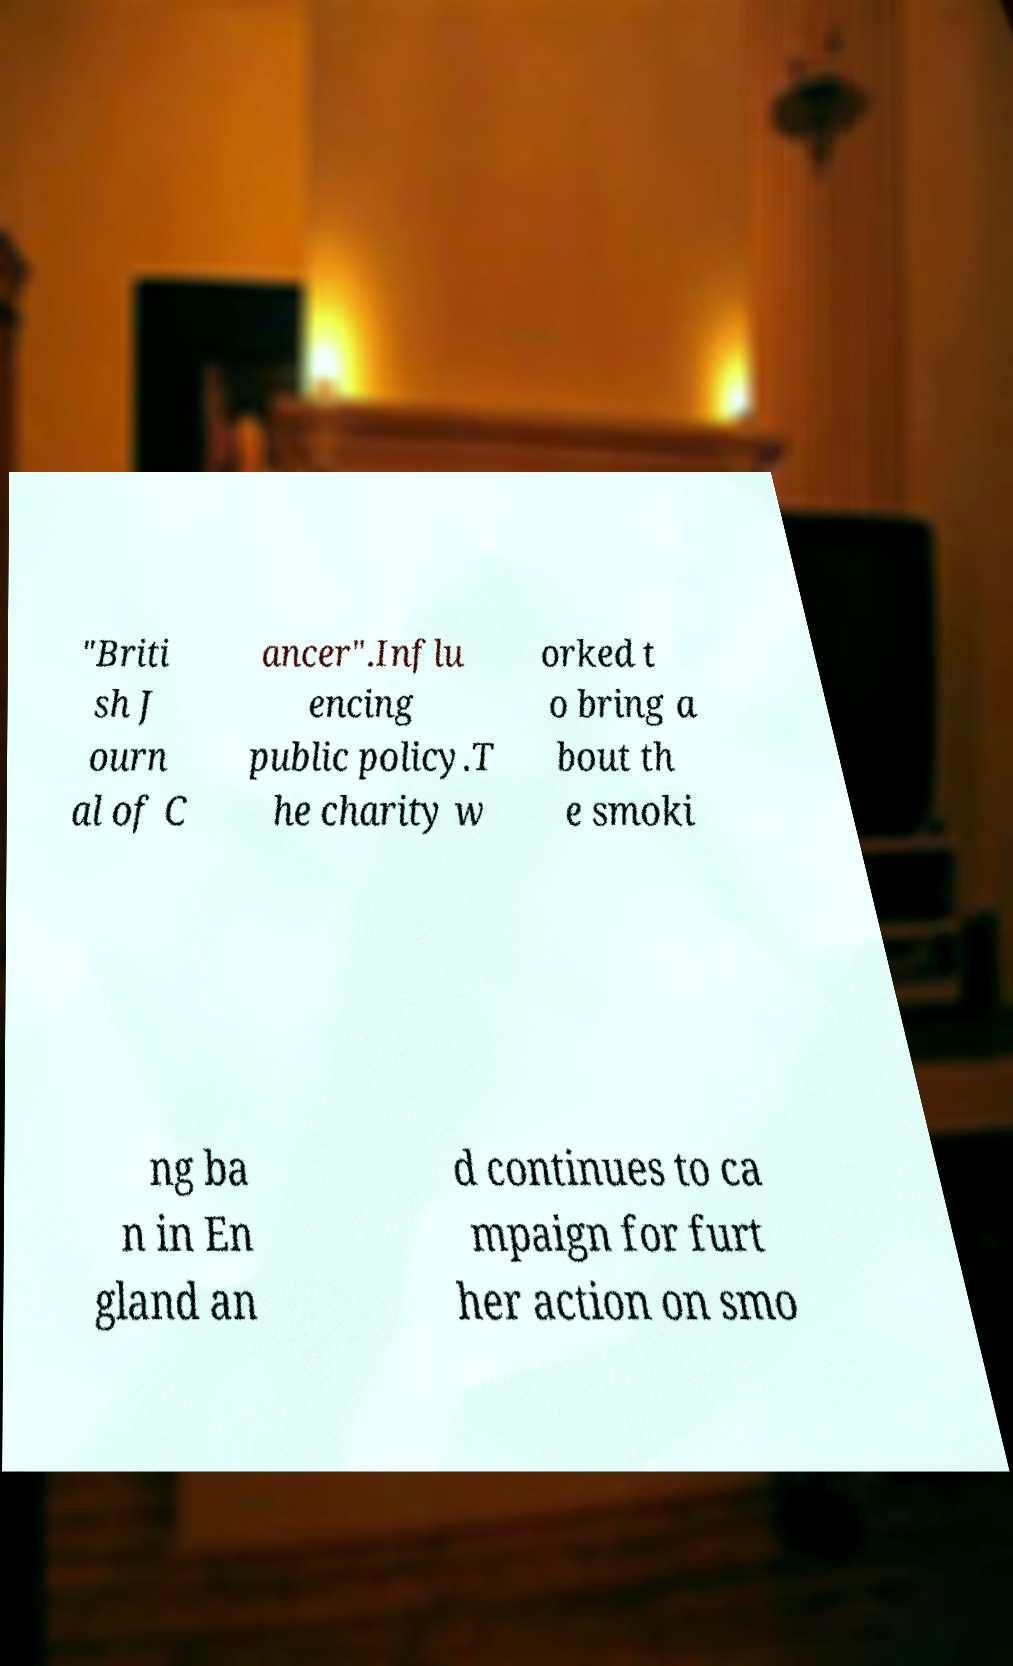There's text embedded in this image that I need extracted. Can you transcribe it verbatim? "Briti sh J ourn al of C ancer".Influ encing public policy.T he charity w orked t o bring a bout th e smoki ng ba n in En gland an d continues to ca mpaign for furt her action on smo 